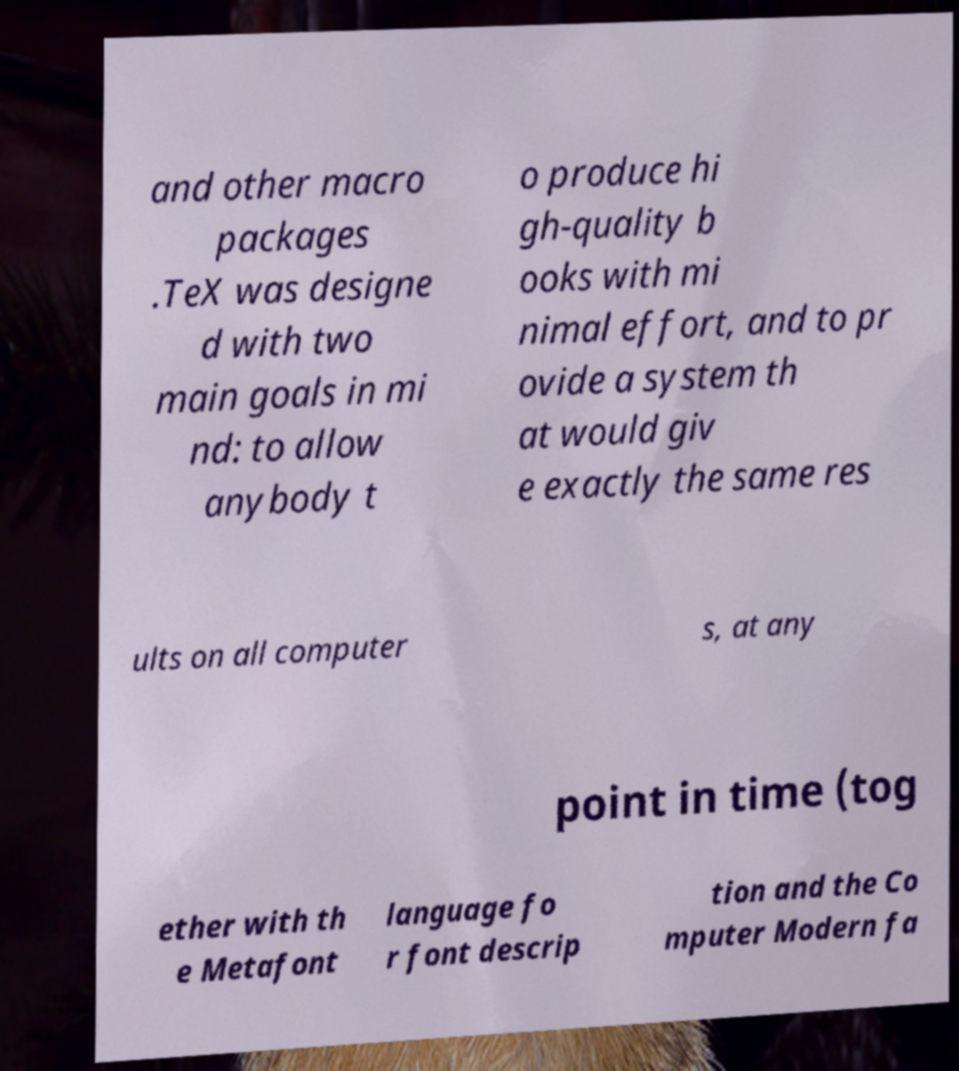Can you accurately transcribe the text from the provided image for me? and other macro packages .TeX was designe d with two main goals in mi nd: to allow anybody t o produce hi gh-quality b ooks with mi nimal effort, and to pr ovide a system th at would giv e exactly the same res ults on all computer s, at any point in time (tog ether with th e Metafont language fo r font descrip tion and the Co mputer Modern fa 